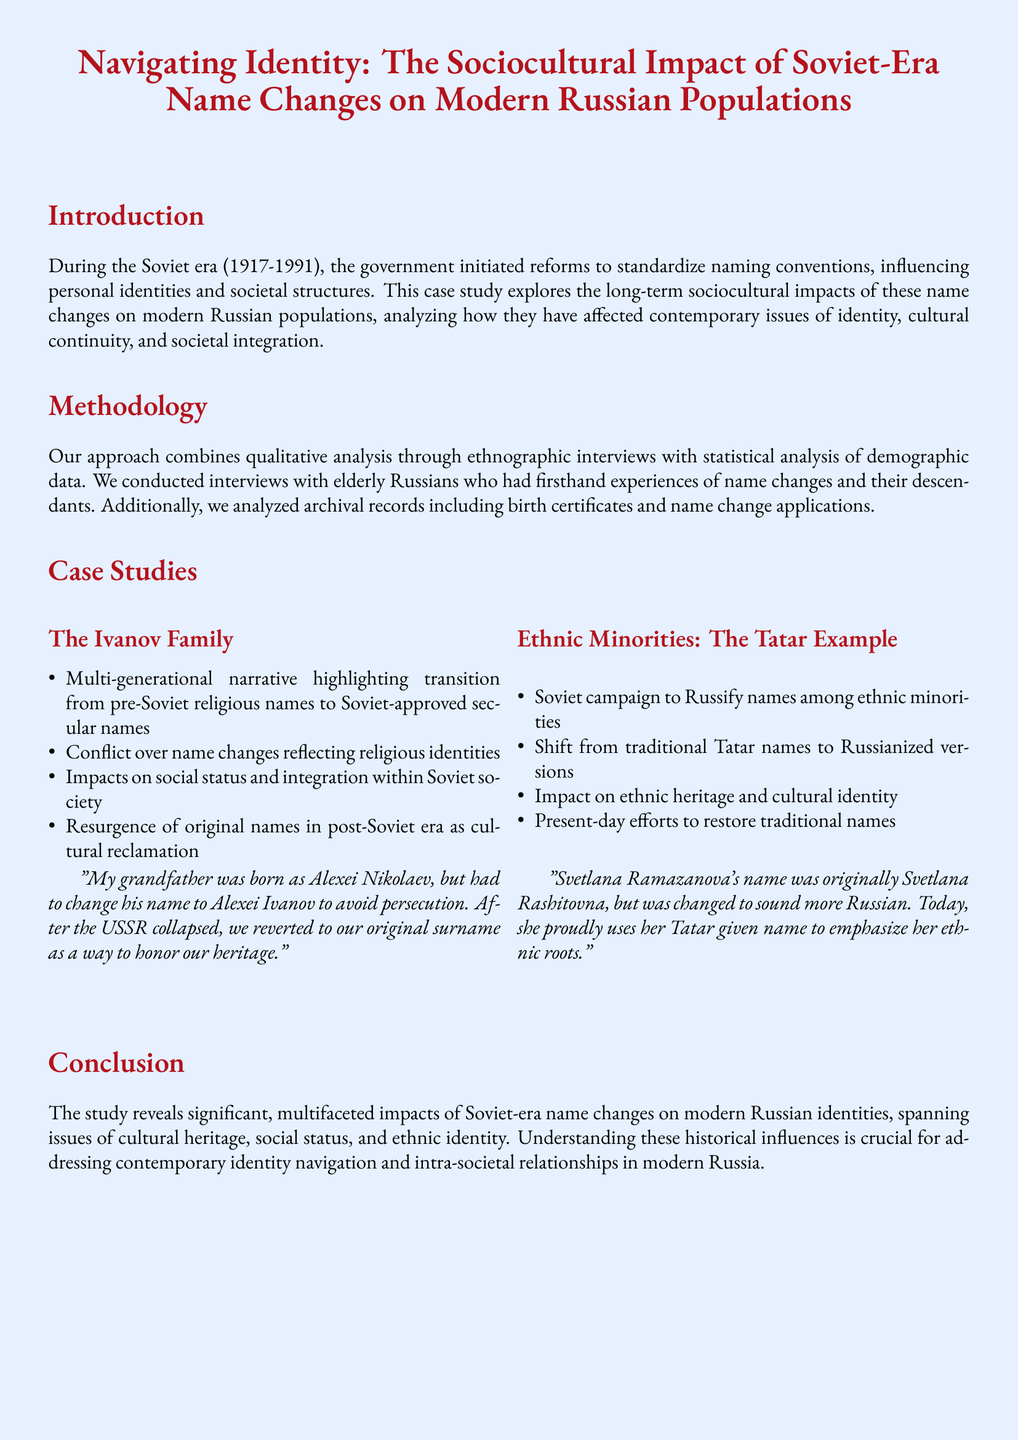What is the time period discussed in the study? The study focuses on name changes during the Soviet era, which ran from 1917 to 1991.
Answer: 1917-1991 Who conducted the interviews for this case study? The case study mentions conducting interviews with elderly Russians and their descendants who experienced name changes.
Answer: Elderly Russians What family is highlighted in the case studies? The study features a multi-generational narrative about the Ivanov family and their experiences with name changes.
Answer: Ivanov Family What was the original name of Svetlana Ramazanova? Svetlana Ramazanova's name was originally Svetlana Rashitovna before it was changed.
Answer: Svetlana Rashitovna What term describes the campaign to Russify names among ethnic minorities? The term used to describe the campaign aimed at changing names among ethnic minorities in the Soviet era is Russification.
Answer: Russification What is a significant outcome of the name changes discussed in the conclusion? A significant outcome mentioned in the conclusion is the resurgence of cultural heritage and original names in the post-Soviet era.
Answer: Cultural heritage resurgence Which sociocultural impact is noted in the Ivanov Family case study? The Ivanov Family case study mentions conflicts over name changes which reflect religious identities.
Answer: Religious identities What methodology combines qualitative analysis in this study? The study combines qualitative analysis of ethnographic interviews and statistical analysis of demographic data.
Answer: Ethnographic interviews and statistical analysis 